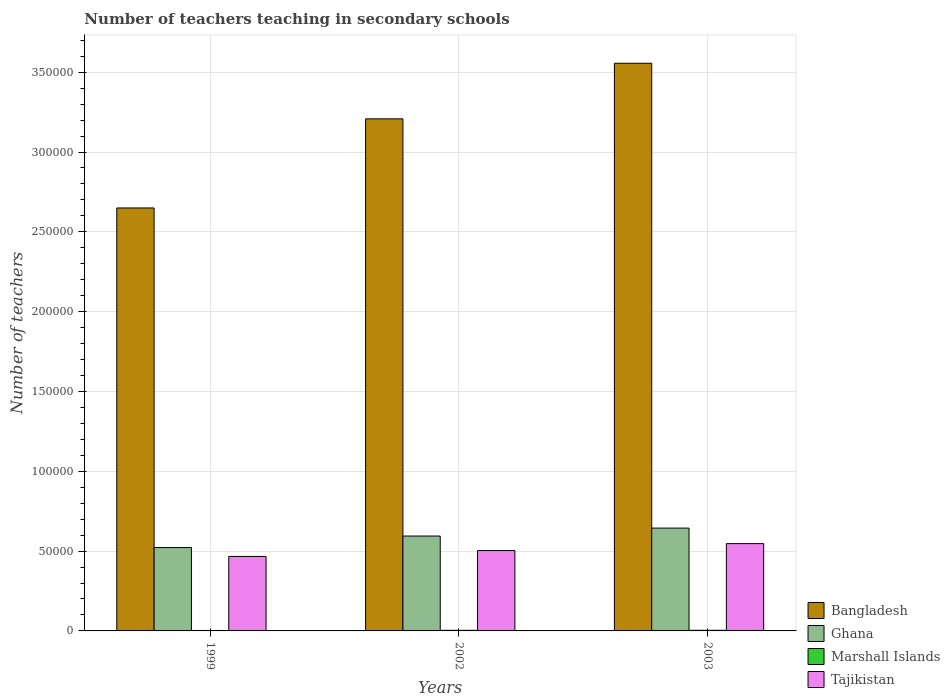How many groups of bars are there?
Provide a succinct answer. 3. Are the number of bars per tick equal to the number of legend labels?
Ensure brevity in your answer.  Yes. How many bars are there on the 3rd tick from the left?
Make the answer very short. 4. How many bars are there on the 2nd tick from the right?
Offer a terse response. 4. What is the label of the 2nd group of bars from the left?
Give a very brief answer. 2002. In how many cases, is the number of bars for a given year not equal to the number of legend labels?
Give a very brief answer. 0. What is the number of teachers teaching in secondary schools in Marshall Islands in 1999?
Provide a short and direct response. 276. Across all years, what is the maximum number of teachers teaching in secondary schools in Tajikistan?
Your answer should be compact. 5.47e+04. Across all years, what is the minimum number of teachers teaching in secondary schools in Marshall Islands?
Provide a short and direct response. 276. In which year was the number of teachers teaching in secondary schools in Tajikistan maximum?
Make the answer very short. 2003. What is the total number of teachers teaching in secondary schools in Bangladesh in the graph?
Offer a terse response. 9.41e+05. What is the difference between the number of teachers teaching in secondary schools in Tajikistan in 2002 and that in 2003?
Your answer should be very brief. -4356. What is the difference between the number of teachers teaching in secondary schools in Bangladesh in 2002 and the number of teachers teaching in secondary schools in Tajikistan in 1999?
Keep it short and to the point. 2.74e+05. What is the average number of teachers teaching in secondary schools in Marshall Islands per year?
Give a very brief answer. 348. In the year 1999, what is the difference between the number of teachers teaching in secondary schools in Bangladesh and number of teachers teaching in secondary schools in Marshall Islands?
Offer a terse response. 2.65e+05. In how many years, is the number of teachers teaching in secondary schools in Tajikistan greater than 340000?
Your answer should be compact. 0. What is the ratio of the number of teachers teaching in secondary schools in Ghana in 1999 to that in 2002?
Your answer should be compact. 0.88. What is the difference between the highest and the second highest number of teachers teaching in secondary schools in Tajikistan?
Offer a very short reply. 4356. What is the difference between the highest and the lowest number of teachers teaching in secondary schools in Ghana?
Your answer should be very brief. 1.22e+04. In how many years, is the number of teachers teaching in secondary schools in Tajikistan greater than the average number of teachers teaching in secondary schools in Tajikistan taken over all years?
Give a very brief answer. 1. Is it the case that in every year, the sum of the number of teachers teaching in secondary schools in Bangladesh and number of teachers teaching in secondary schools in Marshall Islands is greater than the sum of number of teachers teaching in secondary schools in Tajikistan and number of teachers teaching in secondary schools in Ghana?
Keep it short and to the point. Yes. What does the 4th bar from the right in 2003 represents?
Keep it short and to the point. Bangladesh. Is it the case that in every year, the sum of the number of teachers teaching in secondary schools in Marshall Islands and number of teachers teaching in secondary schools in Tajikistan is greater than the number of teachers teaching in secondary schools in Ghana?
Your answer should be compact. No. Are all the bars in the graph horizontal?
Provide a succinct answer. No. Does the graph contain any zero values?
Offer a very short reply. No. What is the title of the graph?
Make the answer very short. Number of teachers teaching in secondary schools. Does "Turkey" appear as one of the legend labels in the graph?
Your answer should be compact. No. What is the label or title of the X-axis?
Offer a very short reply. Years. What is the label or title of the Y-axis?
Offer a terse response. Number of teachers. What is the Number of teachers of Bangladesh in 1999?
Ensure brevity in your answer.  2.65e+05. What is the Number of teachers in Ghana in 1999?
Your answer should be very brief. 5.22e+04. What is the Number of teachers of Marshall Islands in 1999?
Make the answer very short. 276. What is the Number of teachers in Tajikistan in 1999?
Provide a short and direct response. 4.67e+04. What is the Number of teachers of Bangladesh in 2002?
Your answer should be very brief. 3.21e+05. What is the Number of teachers in Ghana in 2002?
Offer a terse response. 5.94e+04. What is the Number of teachers in Marshall Islands in 2002?
Offer a terse response. 381. What is the Number of teachers in Tajikistan in 2002?
Your answer should be very brief. 5.03e+04. What is the Number of teachers of Bangladesh in 2003?
Make the answer very short. 3.56e+05. What is the Number of teachers of Ghana in 2003?
Offer a very short reply. 6.44e+04. What is the Number of teachers in Marshall Islands in 2003?
Offer a very short reply. 387. What is the Number of teachers of Tajikistan in 2003?
Your answer should be very brief. 5.47e+04. Across all years, what is the maximum Number of teachers of Bangladesh?
Offer a terse response. 3.56e+05. Across all years, what is the maximum Number of teachers of Ghana?
Ensure brevity in your answer.  6.44e+04. Across all years, what is the maximum Number of teachers in Marshall Islands?
Give a very brief answer. 387. Across all years, what is the maximum Number of teachers of Tajikistan?
Ensure brevity in your answer.  5.47e+04. Across all years, what is the minimum Number of teachers of Bangladesh?
Give a very brief answer. 2.65e+05. Across all years, what is the minimum Number of teachers of Ghana?
Your answer should be compact. 5.22e+04. Across all years, what is the minimum Number of teachers of Marshall Islands?
Your response must be concise. 276. Across all years, what is the minimum Number of teachers in Tajikistan?
Your response must be concise. 4.67e+04. What is the total Number of teachers in Bangladesh in the graph?
Your answer should be very brief. 9.41e+05. What is the total Number of teachers of Ghana in the graph?
Offer a very short reply. 1.76e+05. What is the total Number of teachers of Marshall Islands in the graph?
Your answer should be compact. 1044. What is the total Number of teachers in Tajikistan in the graph?
Keep it short and to the point. 1.52e+05. What is the difference between the Number of teachers of Bangladesh in 1999 and that in 2002?
Your answer should be compact. -5.58e+04. What is the difference between the Number of teachers in Ghana in 1999 and that in 2002?
Offer a very short reply. -7230. What is the difference between the Number of teachers of Marshall Islands in 1999 and that in 2002?
Your answer should be very brief. -105. What is the difference between the Number of teachers in Tajikistan in 1999 and that in 2002?
Offer a terse response. -3680. What is the difference between the Number of teachers of Bangladesh in 1999 and that in 2003?
Your answer should be very brief. -9.06e+04. What is the difference between the Number of teachers in Ghana in 1999 and that in 2003?
Offer a terse response. -1.22e+04. What is the difference between the Number of teachers in Marshall Islands in 1999 and that in 2003?
Ensure brevity in your answer.  -111. What is the difference between the Number of teachers in Tajikistan in 1999 and that in 2003?
Provide a succinct answer. -8036. What is the difference between the Number of teachers of Bangladesh in 2002 and that in 2003?
Your answer should be compact. -3.48e+04. What is the difference between the Number of teachers in Ghana in 2002 and that in 2003?
Offer a terse response. -4981. What is the difference between the Number of teachers of Tajikistan in 2002 and that in 2003?
Keep it short and to the point. -4356. What is the difference between the Number of teachers of Bangladesh in 1999 and the Number of teachers of Ghana in 2002?
Your response must be concise. 2.06e+05. What is the difference between the Number of teachers of Bangladesh in 1999 and the Number of teachers of Marshall Islands in 2002?
Offer a very short reply. 2.65e+05. What is the difference between the Number of teachers of Bangladesh in 1999 and the Number of teachers of Tajikistan in 2002?
Provide a short and direct response. 2.15e+05. What is the difference between the Number of teachers of Ghana in 1999 and the Number of teachers of Marshall Islands in 2002?
Give a very brief answer. 5.18e+04. What is the difference between the Number of teachers in Ghana in 1999 and the Number of teachers in Tajikistan in 2002?
Provide a succinct answer. 1871. What is the difference between the Number of teachers of Marshall Islands in 1999 and the Number of teachers of Tajikistan in 2002?
Your response must be concise. -5.01e+04. What is the difference between the Number of teachers in Bangladesh in 1999 and the Number of teachers in Ghana in 2003?
Provide a short and direct response. 2.01e+05. What is the difference between the Number of teachers of Bangladesh in 1999 and the Number of teachers of Marshall Islands in 2003?
Give a very brief answer. 2.65e+05. What is the difference between the Number of teachers of Bangladesh in 1999 and the Number of teachers of Tajikistan in 2003?
Your response must be concise. 2.10e+05. What is the difference between the Number of teachers in Ghana in 1999 and the Number of teachers in Marshall Islands in 2003?
Offer a terse response. 5.18e+04. What is the difference between the Number of teachers in Ghana in 1999 and the Number of teachers in Tajikistan in 2003?
Offer a very short reply. -2485. What is the difference between the Number of teachers in Marshall Islands in 1999 and the Number of teachers in Tajikistan in 2003?
Make the answer very short. -5.44e+04. What is the difference between the Number of teachers in Bangladesh in 2002 and the Number of teachers in Ghana in 2003?
Offer a very short reply. 2.56e+05. What is the difference between the Number of teachers in Bangladesh in 2002 and the Number of teachers in Marshall Islands in 2003?
Your answer should be very brief. 3.20e+05. What is the difference between the Number of teachers in Bangladesh in 2002 and the Number of teachers in Tajikistan in 2003?
Provide a succinct answer. 2.66e+05. What is the difference between the Number of teachers of Ghana in 2002 and the Number of teachers of Marshall Islands in 2003?
Give a very brief answer. 5.91e+04. What is the difference between the Number of teachers of Ghana in 2002 and the Number of teachers of Tajikistan in 2003?
Provide a short and direct response. 4745. What is the difference between the Number of teachers in Marshall Islands in 2002 and the Number of teachers in Tajikistan in 2003?
Your answer should be compact. -5.43e+04. What is the average Number of teachers in Bangladesh per year?
Your response must be concise. 3.14e+05. What is the average Number of teachers in Ghana per year?
Make the answer very short. 5.87e+04. What is the average Number of teachers in Marshall Islands per year?
Your response must be concise. 348. What is the average Number of teachers in Tajikistan per year?
Offer a very short reply. 5.06e+04. In the year 1999, what is the difference between the Number of teachers in Bangladesh and Number of teachers in Ghana?
Keep it short and to the point. 2.13e+05. In the year 1999, what is the difference between the Number of teachers in Bangladesh and Number of teachers in Marshall Islands?
Offer a terse response. 2.65e+05. In the year 1999, what is the difference between the Number of teachers in Bangladesh and Number of teachers in Tajikistan?
Offer a terse response. 2.18e+05. In the year 1999, what is the difference between the Number of teachers of Ghana and Number of teachers of Marshall Islands?
Make the answer very short. 5.19e+04. In the year 1999, what is the difference between the Number of teachers in Ghana and Number of teachers in Tajikistan?
Give a very brief answer. 5551. In the year 1999, what is the difference between the Number of teachers of Marshall Islands and Number of teachers of Tajikistan?
Offer a very short reply. -4.64e+04. In the year 2002, what is the difference between the Number of teachers of Bangladesh and Number of teachers of Ghana?
Make the answer very short. 2.61e+05. In the year 2002, what is the difference between the Number of teachers of Bangladesh and Number of teachers of Marshall Islands?
Offer a terse response. 3.20e+05. In the year 2002, what is the difference between the Number of teachers in Bangladesh and Number of teachers in Tajikistan?
Your answer should be compact. 2.70e+05. In the year 2002, what is the difference between the Number of teachers of Ghana and Number of teachers of Marshall Islands?
Give a very brief answer. 5.91e+04. In the year 2002, what is the difference between the Number of teachers of Ghana and Number of teachers of Tajikistan?
Give a very brief answer. 9101. In the year 2002, what is the difference between the Number of teachers of Marshall Islands and Number of teachers of Tajikistan?
Your answer should be compact. -5.00e+04. In the year 2003, what is the difference between the Number of teachers of Bangladesh and Number of teachers of Ghana?
Provide a short and direct response. 2.91e+05. In the year 2003, what is the difference between the Number of teachers in Bangladesh and Number of teachers in Marshall Islands?
Provide a succinct answer. 3.55e+05. In the year 2003, what is the difference between the Number of teachers in Bangladesh and Number of teachers in Tajikistan?
Ensure brevity in your answer.  3.01e+05. In the year 2003, what is the difference between the Number of teachers of Ghana and Number of teachers of Marshall Islands?
Keep it short and to the point. 6.40e+04. In the year 2003, what is the difference between the Number of teachers in Ghana and Number of teachers in Tajikistan?
Your answer should be compact. 9726. In the year 2003, what is the difference between the Number of teachers of Marshall Islands and Number of teachers of Tajikistan?
Offer a very short reply. -5.43e+04. What is the ratio of the Number of teachers of Bangladesh in 1999 to that in 2002?
Your answer should be very brief. 0.83. What is the ratio of the Number of teachers of Ghana in 1999 to that in 2002?
Provide a short and direct response. 0.88. What is the ratio of the Number of teachers in Marshall Islands in 1999 to that in 2002?
Ensure brevity in your answer.  0.72. What is the ratio of the Number of teachers in Tajikistan in 1999 to that in 2002?
Provide a succinct answer. 0.93. What is the ratio of the Number of teachers in Bangladesh in 1999 to that in 2003?
Keep it short and to the point. 0.75. What is the ratio of the Number of teachers in Ghana in 1999 to that in 2003?
Your answer should be very brief. 0.81. What is the ratio of the Number of teachers of Marshall Islands in 1999 to that in 2003?
Offer a terse response. 0.71. What is the ratio of the Number of teachers of Tajikistan in 1999 to that in 2003?
Provide a short and direct response. 0.85. What is the ratio of the Number of teachers in Bangladesh in 2002 to that in 2003?
Your response must be concise. 0.9. What is the ratio of the Number of teachers of Ghana in 2002 to that in 2003?
Your answer should be compact. 0.92. What is the ratio of the Number of teachers in Marshall Islands in 2002 to that in 2003?
Offer a very short reply. 0.98. What is the ratio of the Number of teachers in Tajikistan in 2002 to that in 2003?
Your answer should be compact. 0.92. What is the difference between the highest and the second highest Number of teachers in Bangladesh?
Offer a very short reply. 3.48e+04. What is the difference between the highest and the second highest Number of teachers of Ghana?
Your response must be concise. 4981. What is the difference between the highest and the second highest Number of teachers in Marshall Islands?
Provide a succinct answer. 6. What is the difference between the highest and the second highest Number of teachers in Tajikistan?
Keep it short and to the point. 4356. What is the difference between the highest and the lowest Number of teachers in Bangladesh?
Your answer should be compact. 9.06e+04. What is the difference between the highest and the lowest Number of teachers of Ghana?
Offer a very short reply. 1.22e+04. What is the difference between the highest and the lowest Number of teachers in Marshall Islands?
Offer a terse response. 111. What is the difference between the highest and the lowest Number of teachers of Tajikistan?
Offer a terse response. 8036. 